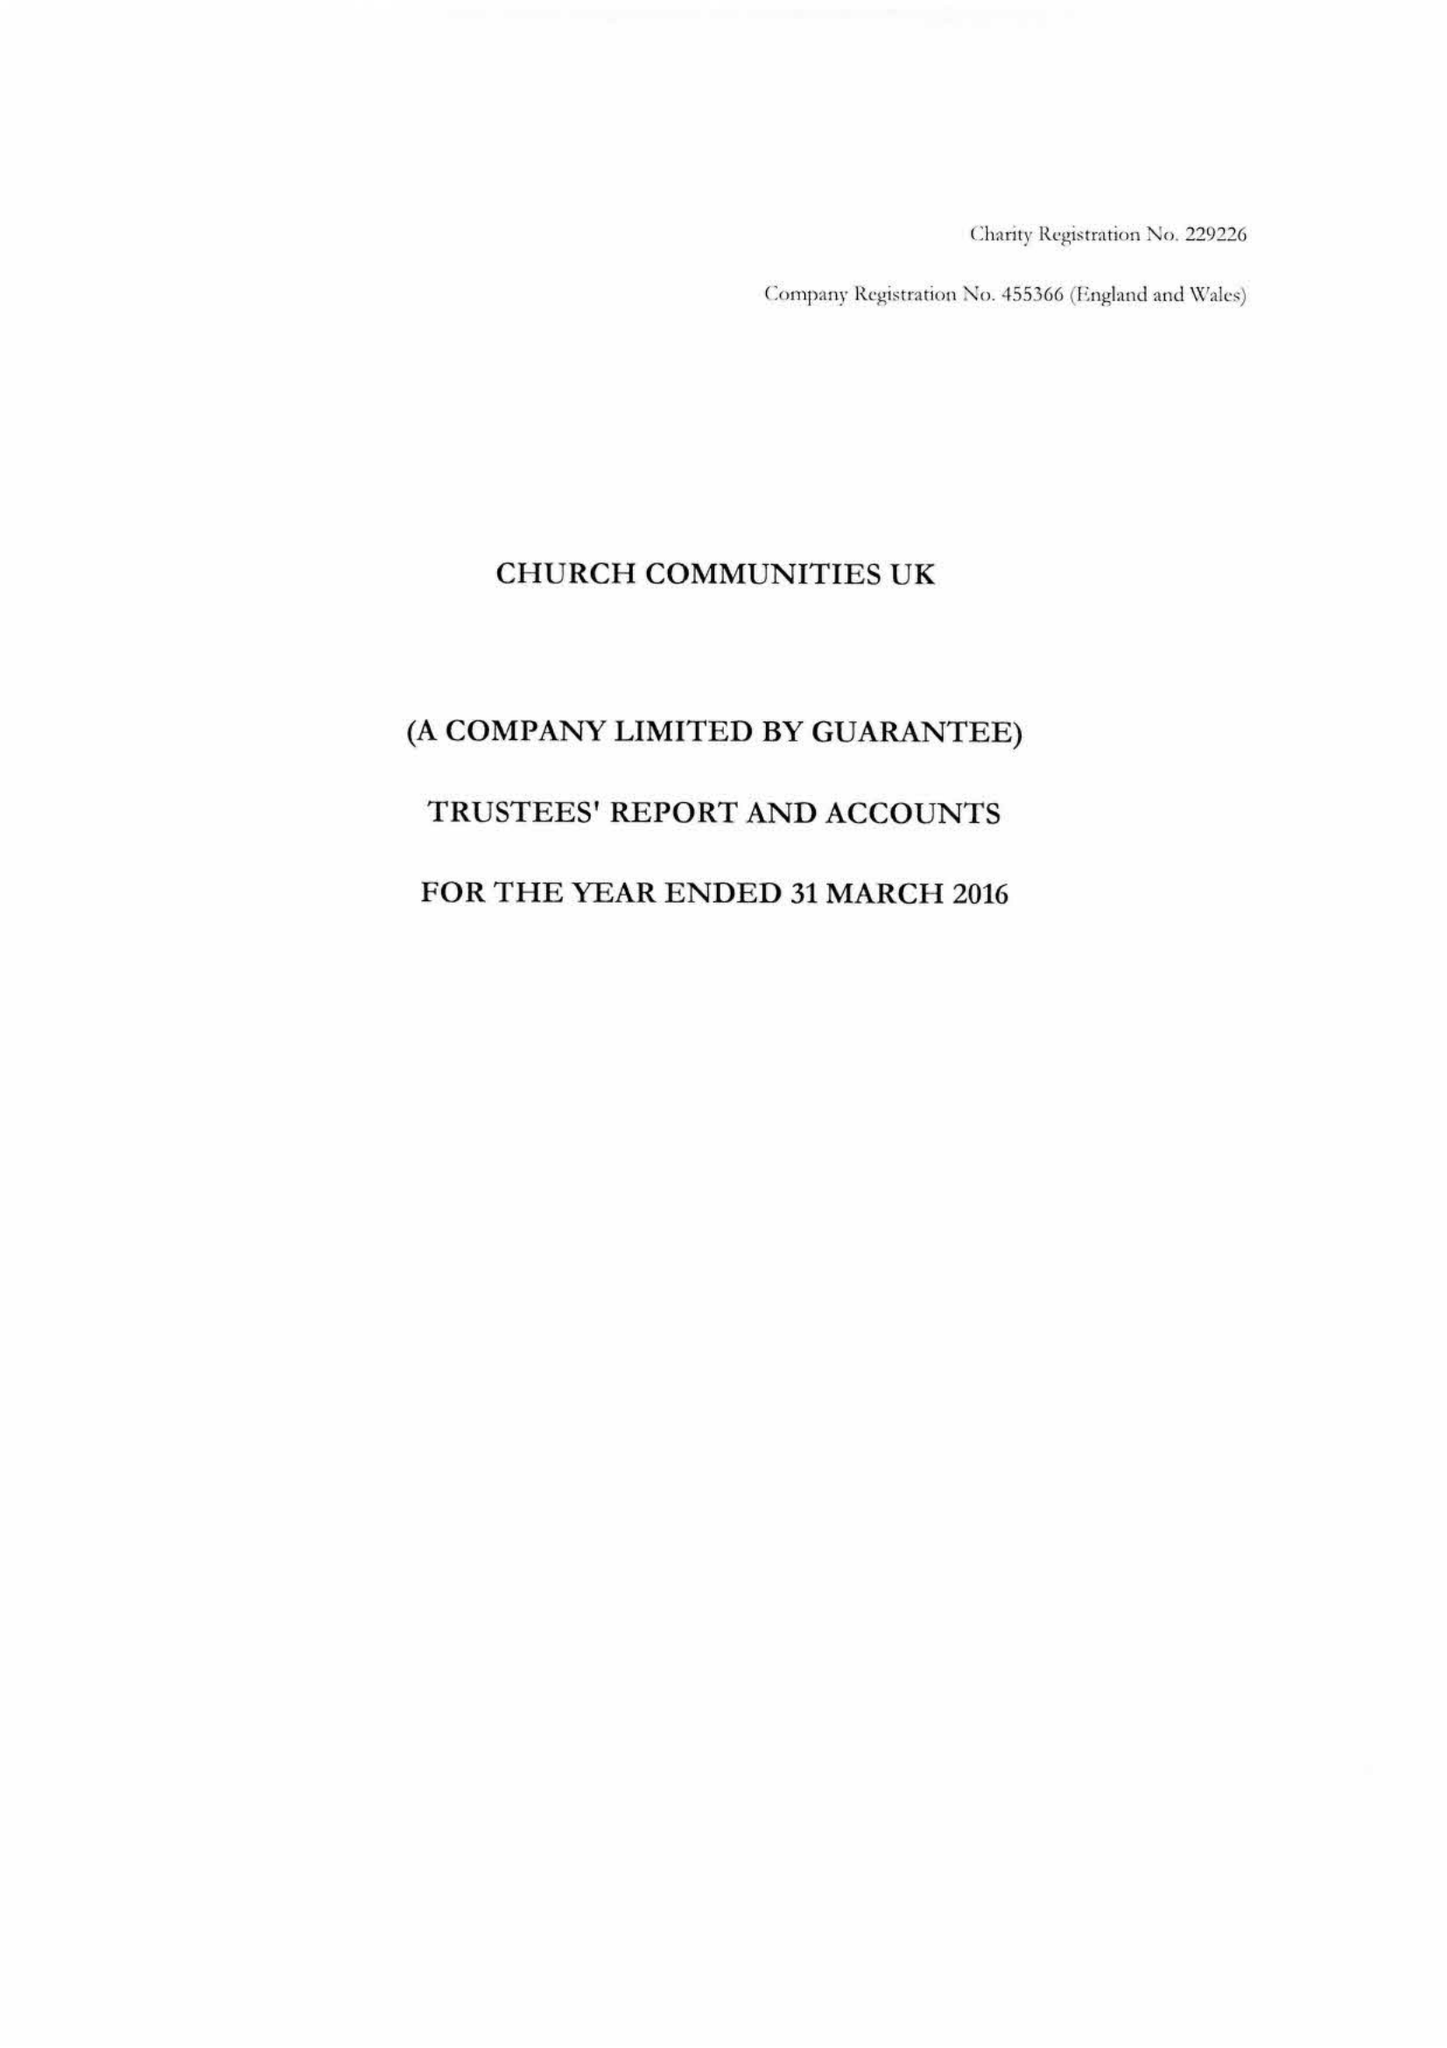What is the value for the address__street_line?
Answer the question using a single word or phrase. BRIGHTLING ROAD 